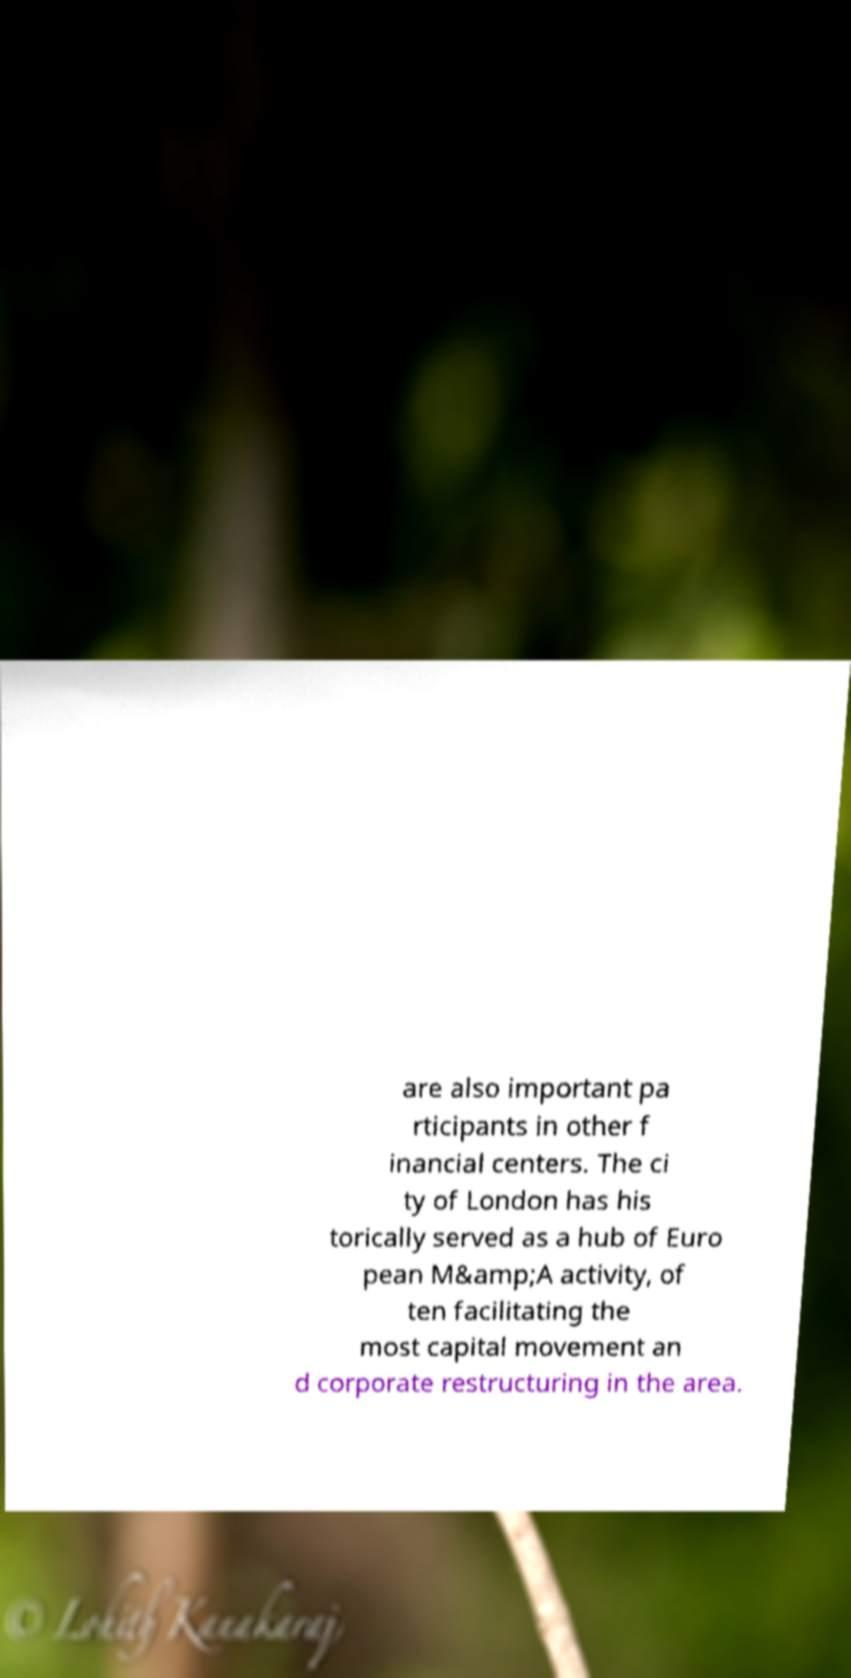Could you extract and type out the text from this image? are also important pa rticipants in other f inancial centers. The ci ty of London has his torically served as a hub of Euro pean M&amp;A activity, of ten facilitating the most capital movement an d corporate restructuring in the area. 